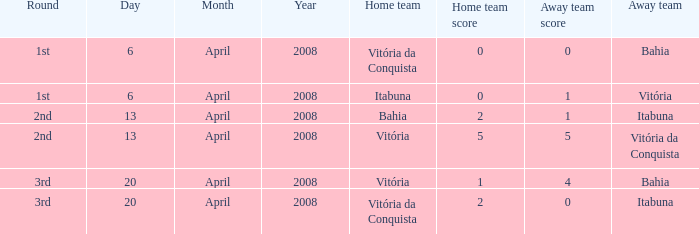Which home side has a score of 5 - 5? Vitória. 